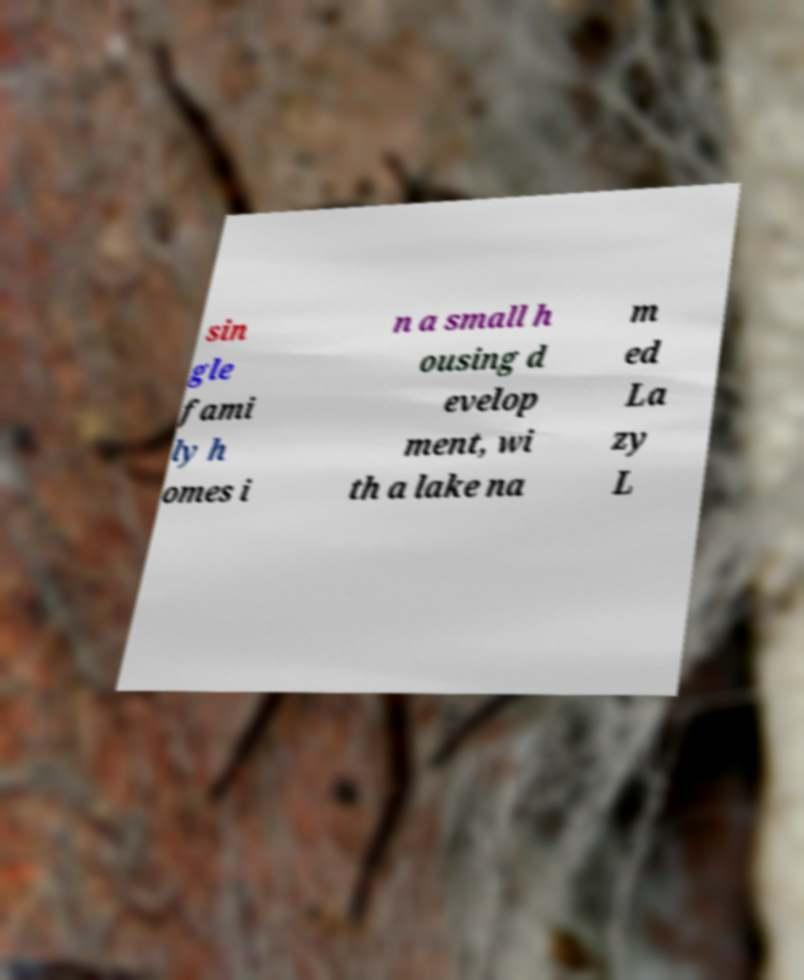For documentation purposes, I need the text within this image transcribed. Could you provide that? sin gle fami ly h omes i n a small h ousing d evelop ment, wi th a lake na m ed La zy L 